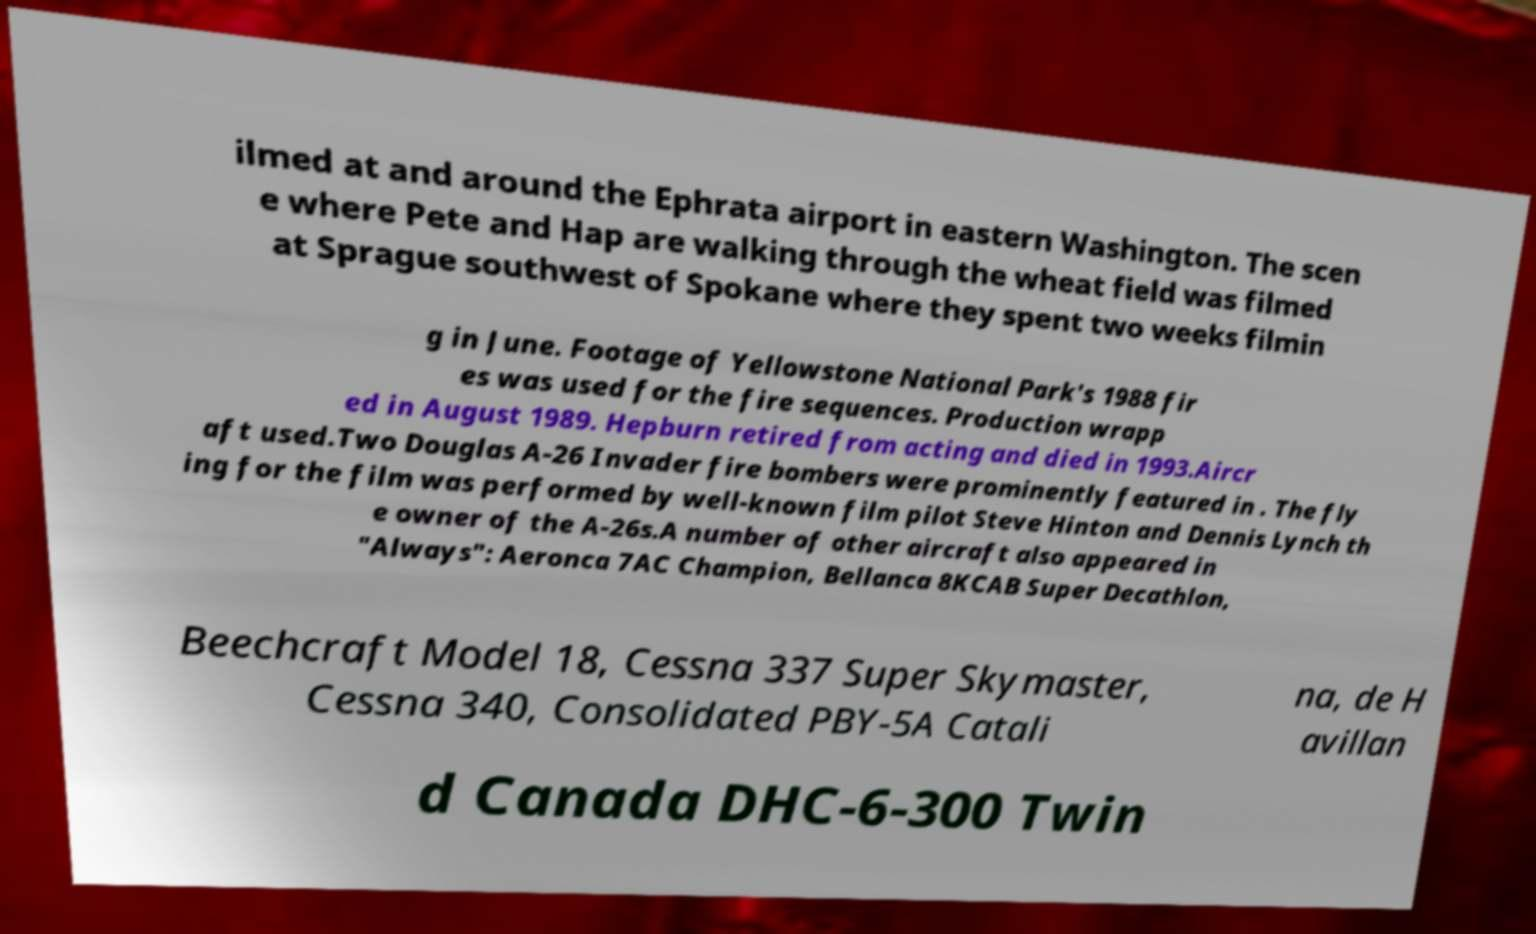Can you read and provide the text displayed in the image?This photo seems to have some interesting text. Can you extract and type it out for me? ilmed at and around the Ephrata airport in eastern Washington. The scen e where Pete and Hap are walking through the wheat field was filmed at Sprague southwest of Spokane where they spent two weeks filmin g in June. Footage of Yellowstone National Park's 1988 fir es was used for the fire sequences. Production wrapp ed in August 1989. Hepburn retired from acting and died in 1993.Aircr aft used.Two Douglas A-26 Invader fire bombers were prominently featured in . The fly ing for the film was performed by well-known film pilot Steve Hinton and Dennis Lynch th e owner of the A-26s.A number of other aircraft also appeared in "Always": Aeronca 7AC Champion, Bellanca 8KCAB Super Decathlon, Beechcraft Model 18, Cessna 337 Super Skymaster, Cessna 340, Consolidated PBY-5A Catali na, de H avillan d Canada DHC-6-300 Twin 